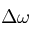<formula> <loc_0><loc_0><loc_500><loc_500>\Delta \omega</formula> 